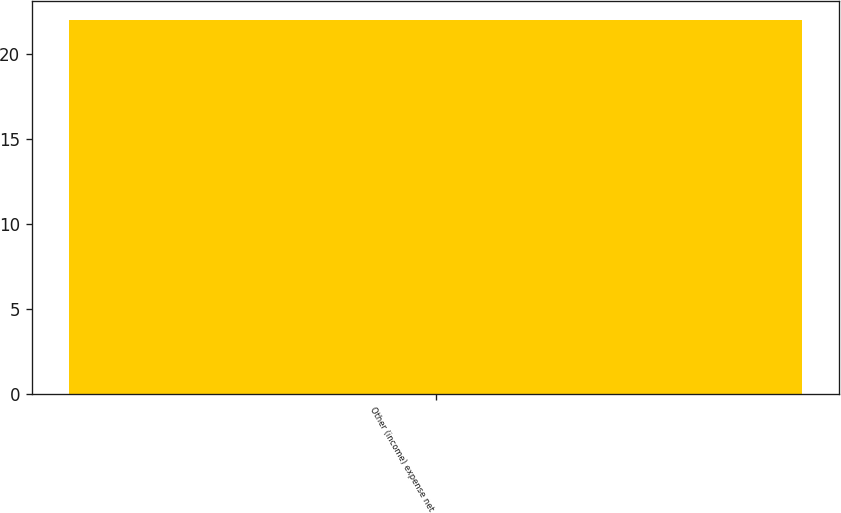Convert chart. <chart><loc_0><loc_0><loc_500><loc_500><bar_chart><fcel>Other (income) expense net<nl><fcel>22<nl></chart> 